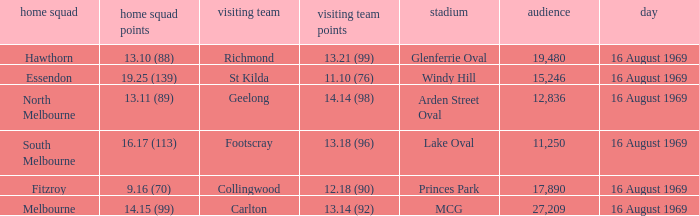Who was home at Princes Park? 9.16 (70). 